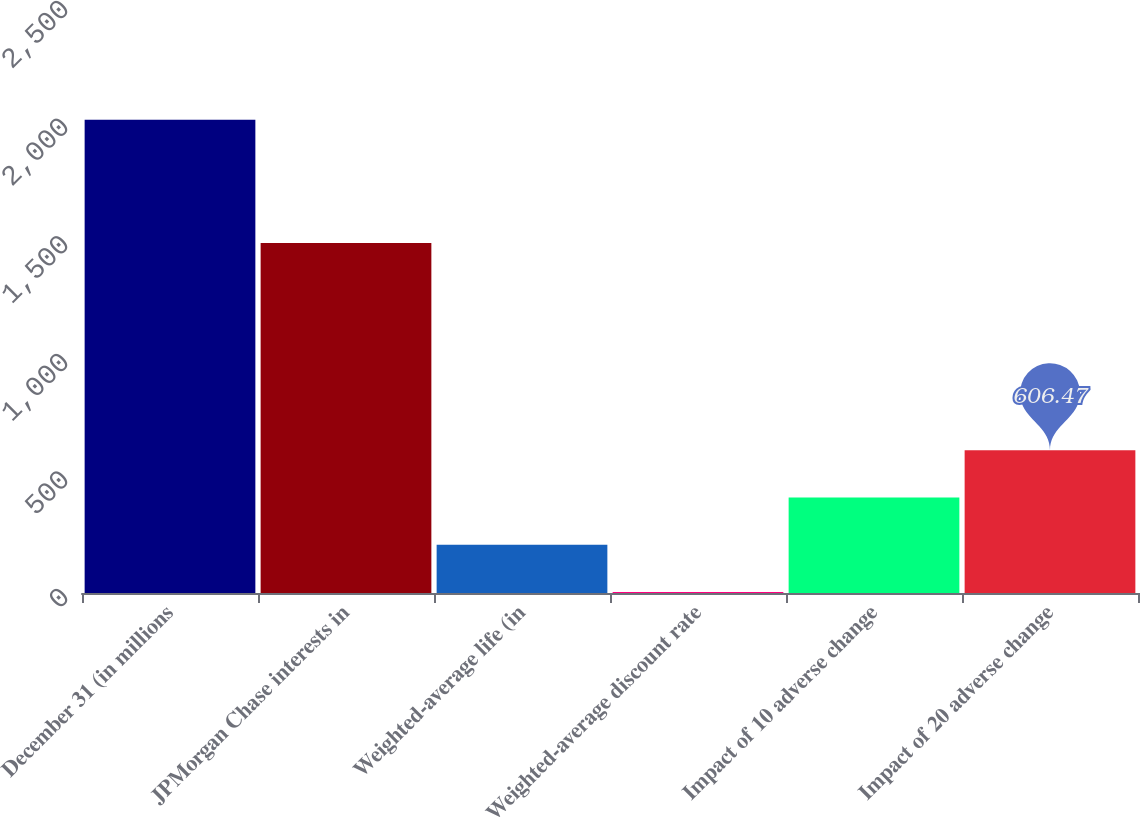Convert chart to OTSL. <chart><loc_0><loc_0><loc_500><loc_500><bar_chart><fcel>December 31 (in millions<fcel>JPMorgan Chase interests in<fcel>Weighted-average life (in<fcel>Weighted-average discount rate<fcel>Impact of 10 adverse change<fcel>Impact of 20 adverse change<nl><fcel>2012<fcel>1488<fcel>204.89<fcel>4.1<fcel>405.68<fcel>606.47<nl></chart> 